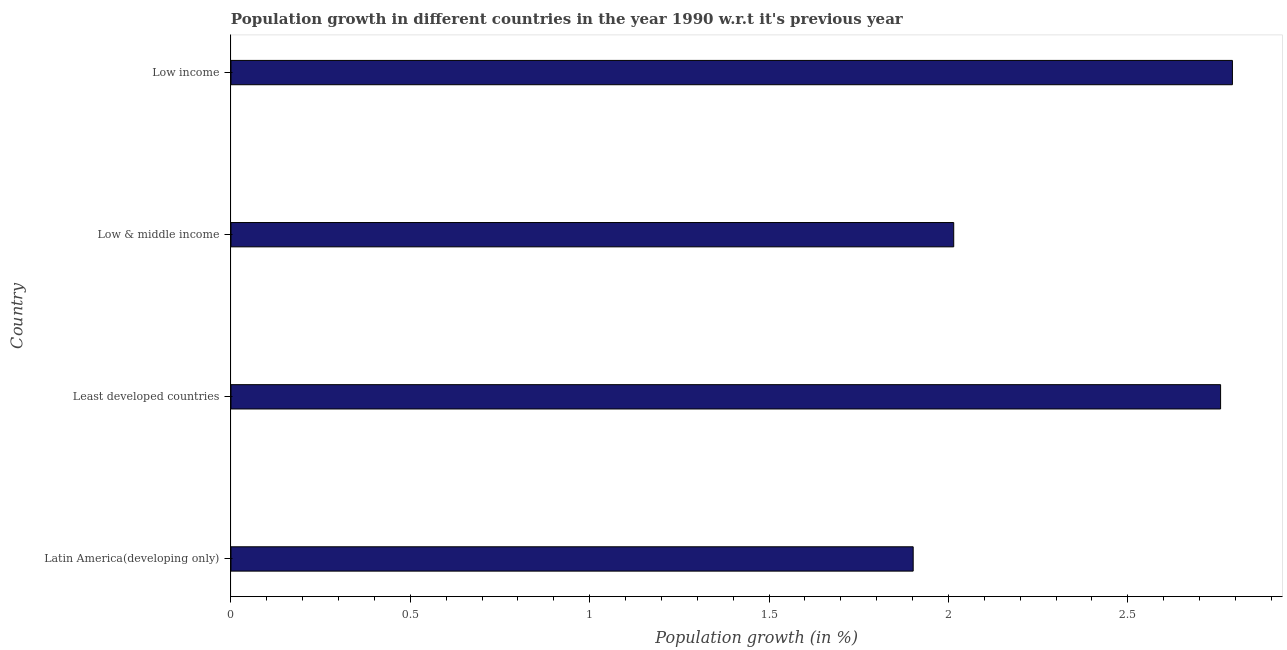Does the graph contain grids?
Provide a short and direct response. No. What is the title of the graph?
Provide a succinct answer. Population growth in different countries in the year 1990 w.r.t it's previous year. What is the label or title of the X-axis?
Give a very brief answer. Population growth (in %). What is the population growth in Low income?
Your answer should be compact. 2.79. Across all countries, what is the maximum population growth?
Your answer should be compact. 2.79. Across all countries, what is the minimum population growth?
Your response must be concise. 1.9. In which country was the population growth minimum?
Give a very brief answer. Latin America(developing only). What is the sum of the population growth?
Offer a terse response. 9.47. What is the difference between the population growth in Latin America(developing only) and Low & middle income?
Give a very brief answer. -0.11. What is the average population growth per country?
Give a very brief answer. 2.37. What is the median population growth?
Your answer should be compact. 2.39. What is the ratio of the population growth in Latin America(developing only) to that in Least developed countries?
Provide a succinct answer. 0.69. Is the population growth in Low & middle income less than that in Low income?
Your answer should be compact. Yes. What is the difference between the highest and the second highest population growth?
Your answer should be compact. 0.03. What is the difference between the highest and the lowest population growth?
Make the answer very short. 0.89. How many bars are there?
Give a very brief answer. 4. Are all the bars in the graph horizontal?
Offer a terse response. Yes. How many countries are there in the graph?
Keep it short and to the point. 4. What is the difference between two consecutive major ticks on the X-axis?
Your answer should be compact. 0.5. What is the Population growth (in %) of Latin America(developing only)?
Offer a terse response. 1.9. What is the Population growth (in %) of Least developed countries?
Your answer should be very brief. 2.76. What is the Population growth (in %) of Low & middle income?
Give a very brief answer. 2.01. What is the Population growth (in %) in Low income?
Provide a short and direct response. 2.79. What is the difference between the Population growth (in %) in Latin America(developing only) and Least developed countries?
Provide a succinct answer. -0.86. What is the difference between the Population growth (in %) in Latin America(developing only) and Low & middle income?
Provide a succinct answer. -0.11. What is the difference between the Population growth (in %) in Latin America(developing only) and Low income?
Provide a short and direct response. -0.89. What is the difference between the Population growth (in %) in Least developed countries and Low & middle income?
Make the answer very short. 0.74. What is the difference between the Population growth (in %) in Least developed countries and Low income?
Offer a very short reply. -0.03. What is the difference between the Population growth (in %) in Low & middle income and Low income?
Offer a terse response. -0.78. What is the ratio of the Population growth (in %) in Latin America(developing only) to that in Least developed countries?
Make the answer very short. 0.69. What is the ratio of the Population growth (in %) in Latin America(developing only) to that in Low & middle income?
Offer a terse response. 0.94. What is the ratio of the Population growth (in %) in Latin America(developing only) to that in Low income?
Your response must be concise. 0.68. What is the ratio of the Population growth (in %) in Least developed countries to that in Low & middle income?
Give a very brief answer. 1.37. What is the ratio of the Population growth (in %) in Least developed countries to that in Low income?
Provide a short and direct response. 0.99. What is the ratio of the Population growth (in %) in Low & middle income to that in Low income?
Keep it short and to the point. 0.72. 